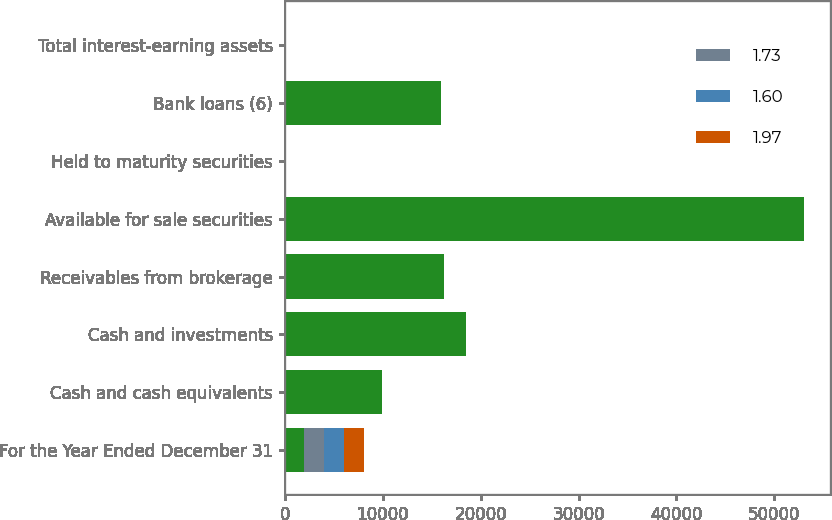Convert chart to OTSL. <chart><loc_0><loc_0><loc_500><loc_500><stacked_bar_chart><ecel><fcel>For the Year Ended December 31<fcel>Cash and cash equivalents<fcel>Cash and investments<fcel>Receivables from brokerage<fcel>Available for sale securities<fcel>Held to maturity securities<fcel>Bank loans (6)<fcel>Total interest-earning assets<nl><fcel>nan<fcel>2017<fcel>9931<fcel>18525<fcel>16269<fcel>53040<fcel>2.57<fcel>15919<fcel>2.57<nl><fcel>1.73<fcel>2017<fcel>1.1<fcel>0.9<fcel>3.53<fcel>1.54<fcel>2.27<fcel>2.97<fcel>2.06<nl><fcel>1.6<fcel>2016<fcel>0.51<fcel>0.46<fcel>3.31<fcel>1.22<fcel>2.44<fcel>2.72<fcel>1.74<nl><fcel>1.97<fcel>2015<fcel>0.26<fcel>0.17<fcel>3.3<fcel>1.01<fcel>2.5<fcel>2.64<fcel>1.59<nl></chart> 